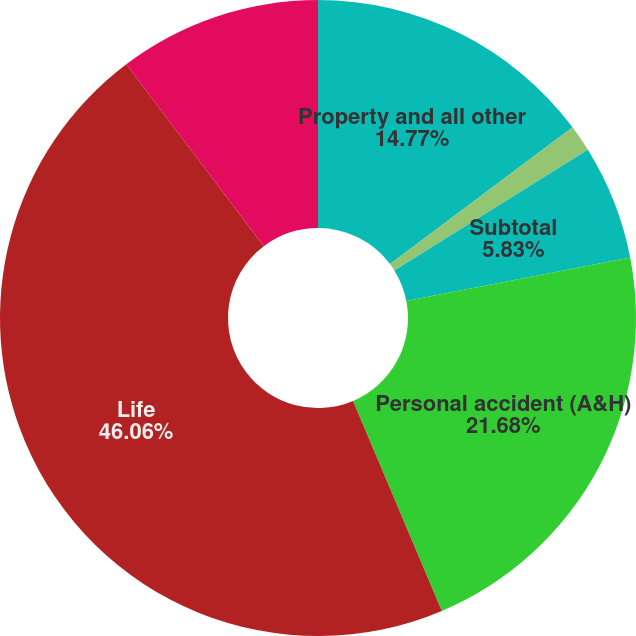Convert chart. <chart><loc_0><loc_0><loc_500><loc_500><pie_chart><fcel>Property and all other<fcel>Casualty<fcel>Subtotal<fcel>Personal accident (A&H)<fcel>Life<fcel>Net premiums earned<nl><fcel>14.77%<fcel>1.36%<fcel>5.83%<fcel>21.68%<fcel>46.07%<fcel>10.3%<nl></chart> 